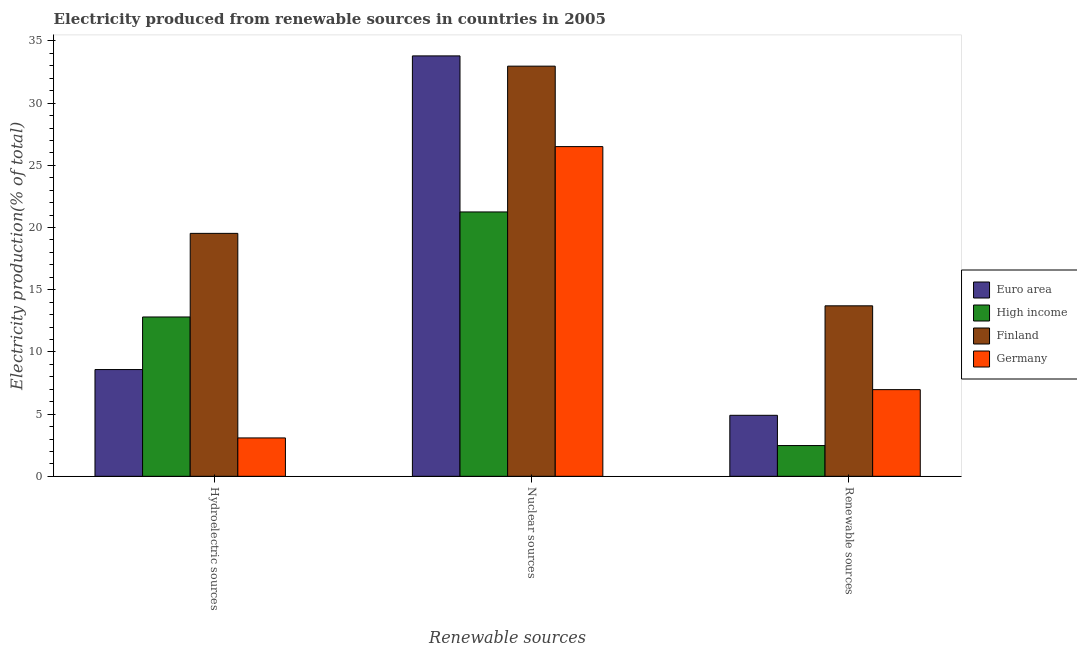How many different coloured bars are there?
Keep it short and to the point. 4. Are the number of bars per tick equal to the number of legend labels?
Offer a very short reply. Yes. Are the number of bars on each tick of the X-axis equal?
Give a very brief answer. Yes. How many bars are there on the 1st tick from the left?
Make the answer very short. 4. What is the label of the 2nd group of bars from the left?
Your response must be concise. Nuclear sources. What is the percentage of electricity produced by nuclear sources in Euro area?
Your response must be concise. 33.8. Across all countries, what is the maximum percentage of electricity produced by hydroelectric sources?
Give a very brief answer. 19.53. Across all countries, what is the minimum percentage of electricity produced by hydroelectric sources?
Offer a terse response. 3.09. In which country was the percentage of electricity produced by renewable sources minimum?
Give a very brief answer. High income. What is the total percentage of electricity produced by nuclear sources in the graph?
Provide a short and direct response. 114.53. What is the difference between the percentage of electricity produced by renewable sources in High income and that in Germany?
Keep it short and to the point. -4.49. What is the difference between the percentage of electricity produced by hydroelectric sources in Euro area and the percentage of electricity produced by nuclear sources in High income?
Your answer should be very brief. -12.67. What is the average percentage of electricity produced by nuclear sources per country?
Your answer should be compact. 28.63. What is the difference between the percentage of electricity produced by nuclear sources and percentage of electricity produced by renewable sources in Germany?
Give a very brief answer. 19.54. What is the ratio of the percentage of electricity produced by renewable sources in Germany to that in High income?
Your answer should be compact. 2.82. Is the percentage of electricity produced by nuclear sources in Euro area less than that in Finland?
Your answer should be compact. No. Is the difference between the percentage of electricity produced by hydroelectric sources in Finland and High income greater than the difference between the percentage of electricity produced by nuclear sources in Finland and High income?
Offer a terse response. No. What is the difference between the highest and the second highest percentage of electricity produced by renewable sources?
Ensure brevity in your answer.  6.74. What is the difference between the highest and the lowest percentage of electricity produced by hydroelectric sources?
Offer a terse response. 16.45. Is the sum of the percentage of electricity produced by hydroelectric sources in Euro area and Germany greater than the maximum percentage of electricity produced by renewable sources across all countries?
Your answer should be very brief. No. What does the 4th bar from the right in Nuclear sources represents?
Give a very brief answer. Euro area. Is it the case that in every country, the sum of the percentage of electricity produced by hydroelectric sources and percentage of electricity produced by nuclear sources is greater than the percentage of electricity produced by renewable sources?
Your answer should be very brief. Yes. What is the difference between two consecutive major ticks on the Y-axis?
Your response must be concise. 5. Does the graph contain any zero values?
Ensure brevity in your answer.  No. Does the graph contain grids?
Offer a terse response. No. Where does the legend appear in the graph?
Offer a terse response. Center right. How are the legend labels stacked?
Offer a very short reply. Vertical. What is the title of the graph?
Provide a short and direct response. Electricity produced from renewable sources in countries in 2005. Does "Gambia, The" appear as one of the legend labels in the graph?
Your answer should be very brief. No. What is the label or title of the X-axis?
Make the answer very short. Renewable sources. What is the Electricity production(% of total) in Euro area in Hydroelectric sources?
Ensure brevity in your answer.  8.58. What is the Electricity production(% of total) in High income in Hydroelectric sources?
Ensure brevity in your answer.  12.81. What is the Electricity production(% of total) of Finland in Hydroelectric sources?
Offer a terse response. 19.53. What is the Electricity production(% of total) in Germany in Hydroelectric sources?
Your answer should be very brief. 3.09. What is the Electricity production(% of total) in Euro area in Nuclear sources?
Your answer should be very brief. 33.8. What is the Electricity production(% of total) in High income in Nuclear sources?
Ensure brevity in your answer.  21.25. What is the Electricity production(% of total) in Finland in Nuclear sources?
Ensure brevity in your answer.  32.97. What is the Electricity production(% of total) of Germany in Nuclear sources?
Give a very brief answer. 26.51. What is the Electricity production(% of total) of Euro area in Renewable sources?
Your response must be concise. 4.91. What is the Electricity production(% of total) in High income in Renewable sources?
Your answer should be compact. 2.47. What is the Electricity production(% of total) of Finland in Renewable sources?
Your answer should be compact. 13.71. What is the Electricity production(% of total) of Germany in Renewable sources?
Provide a succinct answer. 6.97. Across all Renewable sources, what is the maximum Electricity production(% of total) in Euro area?
Ensure brevity in your answer.  33.8. Across all Renewable sources, what is the maximum Electricity production(% of total) in High income?
Your answer should be compact. 21.25. Across all Renewable sources, what is the maximum Electricity production(% of total) in Finland?
Make the answer very short. 32.97. Across all Renewable sources, what is the maximum Electricity production(% of total) in Germany?
Offer a terse response. 26.51. Across all Renewable sources, what is the minimum Electricity production(% of total) in Euro area?
Ensure brevity in your answer.  4.91. Across all Renewable sources, what is the minimum Electricity production(% of total) in High income?
Your response must be concise. 2.47. Across all Renewable sources, what is the minimum Electricity production(% of total) of Finland?
Provide a succinct answer. 13.71. Across all Renewable sources, what is the minimum Electricity production(% of total) of Germany?
Keep it short and to the point. 3.09. What is the total Electricity production(% of total) in Euro area in the graph?
Offer a very short reply. 47.29. What is the total Electricity production(% of total) of High income in the graph?
Provide a succinct answer. 36.54. What is the total Electricity production(% of total) of Finland in the graph?
Give a very brief answer. 66.21. What is the total Electricity production(% of total) of Germany in the graph?
Your answer should be compact. 36.56. What is the difference between the Electricity production(% of total) in Euro area in Hydroelectric sources and that in Nuclear sources?
Provide a succinct answer. -25.22. What is the difference between the Electricity production(% of total) in High income in Hydroelectric sources and that in Nuclear sources?
Provide a succinct answer. -8.44. What is the difference between the Electricity production(% of total) of Finland in Hydroelectric sources and that in Nuclear sources?
Keep it short and to the point. -13.44. What is the difference between the Electricity production(% of total) of Germany in Hydroelectric sources and that in Nuclear sources?
Your answer should be very brief. -23.42. What is the difference between the Electricity production(% of total) in Euro area in Hydroelectric sources and that in Renewable sources?
Make the answer very short. 3.68. What is the difference between the Electricity production(% of total) in High income in Hydroelectric sources and that in Renewable sources?
Offer a very short reply. 10.34. What is the difference between the Electricity production(% of total) in Finland in Hydroelectric sources and that in Renewable sources?
Offer a very short reply. 5.83. What is the difference between the Electricity production(% of total) of Germany in Hydroelectric sources and that in Renewable sources?
Provide a succinct answer. -3.88. What is the difference between the Electricity production(% of total) of Euro area in Nuclear sources and that in Renewable sources?
Keep it short and to the point. 28.89. What is the difference between the Electricity production(% of total) of High income in Nuclear sources and that in Renewable sources?
Offer a very short reply. 18.78. What is the difference between the Electricity production(% of total) of Finland in Nuclear sources and that in Renewable sources?
Offer a very short reply. 19.27. What is the difference between the Electricity production(% of total) of Germany in Nuclear sources and that in Renewable sources?
Give a very brief answer. 19.54. What is the difference between the Electricity production(% of total) of Euro area in Hydroelectric sources and the Electricity production(% of total) of High income in Nuclear sources?
Offer a very short reply. -12.67. What is the difference between the Electricity production(% of total) of Euro area in Hydroelectric sources and the Electricity production(% of total) of Finland in Nuclear sources?
Provide a succinct answer. -24.39. What is the difference between the Electricity production(% of total) of Euro area in Hydroelectric sources and the Electricity production(% of total) of Germany in Nuclear sources?
Offer a very short reply. -17.92. What is the difference between the Electricity production(% of total) in High income in Hydroelectric sources and the Electricity production(% of total) in Finland in Nuclear sources?
Your answer should be compact. -20.17. What is the difference between the Electricity production(% of total) in High income in Hydroelectric sources and the Electricity production(% of total) in Germany in Nuclear sources?
Your answer should be compact. -13.7. What is the difference between the Electricity production(% of total) of Finland in Hydroelectric sources and the Electricity production(% of total) of Germany in Nuclear sources?
Offer a terse response. -6.97. What is the difference between the Electricity production(% of total) of Euro area in Hydroelectric sources and the Electricity production(% of total) of High income in Renewable sources?
Your answer should be very brief. 6.11. What is the difference between the Electricity production(% of total) of Euro area in Hydroelectric sources and the Electricity production(% of total) of Finland in Renewable sources?
Offer a very short reply. -5.12. What is the difference between the Electricity production(% of total) of Euro area in Hydroelectric sources and the Electricity production(% of total) of Germany in Renewable sources?
Your answer should be compact. 1.61. What is the difference between the Electricity production(% of total) of High income in Hydroelectric sources and the Electricity production(% of total) of Finland in Renewable sources?
Your answer should be very brief. -0.9. What is the difference between the Electricity production(% of total) of High income in Hydroelectric sources and the Electricity production(% of total) of Germany in Renewable sources?
Your response must be concise. 5.84. What is the difference between the Electricity production(% of total) in Finland in Hydroelectric sources and the Electricity production(% of total) in Germany in Renewable sources?
Ensure brevity in your answer.  12.56. What is the difference between the Electricity production(% of total) of Euro area in Nuclear sources and the Electricity production(% of total) of High income in Renewable sources?
Provide a succinct answer. 31.32. What is the difference between the Electricity production(% of total) in Euro area in Nuclear sources and the Electricity production(% of total) in Finland in Renewable sources?
Provide a short and direct response. 20.09. What is the difference between the Electricity production(% of total) in Euro area in Nuclear sources and the Electricity production(% of total) in Germany in Renewable sources?
Make the answer very short. 26.83. What is the difference between the Electricity production(% of total) of High income in Nuclear sources and the Electricity production(% of total) of Finland in Renewable sources?
Provide a succinct answer. 7.55. What is the difference between the Electricity production(% of total) in High income in Nuclear sources and the Electricity production(% of total) in Germany in Renewable sources?
Keep it short and to the point. 14.28. What is the difference between the Electricity production(% of total) of Finland in Nuclear sources and the Electricity production(% of total) of Germany in Renewable sources?
Provide a short and direct response. 26.01. What is the average Electricity production(% of total) in Euro area per Renewable sources?
Give a very brief answer. 15.76. What is the average Electricity production(% of total) in High income per Renewable sources?
Make the answer very short. 12.18. What is the average Electricity production(% of total) in Finland per Renewable sources?
Your answer should be compact. 22.07. What is the average Electricity production(% of total) of Germany per Renewable sources?
Offer a very short reply. 12.19. What is the difference between the Electricity production(% of total) of Euro area and Electricity production(% of total) of High income in Hydroelectric sources?
Give a very brief answer. -4.23. What is the difference between the Electricity production(% of total) in Euro area and Electricity production(% of total) in Finland in Hydroelectric sources?
Offer a terse response. -10.95. What is the difference between the Electricity production(% of total) in Euro area and Electricity production(% of total) in Germany in Hydroelectric sources?
Give a very brief answer. 5.5. What is the difference between the Electricity production(% of total) in High income and Electricity production(% of total) in Finland in Hydroelectric sources?
Give a very brief answer. -6.72. What is the difference between the Electricity production(% of total) of High income and Electricity production(% of total) of Germany in Hydroelectric sources?
Ensure brevity in your answer.  9.72. What is the difference between the Electricity production(% of total) in Finland and Electricity production(% of total) in Germany in Hydroelectric sources?
Your answer should be compact. 16.45. What is the difference between the Electricity production(% of total) of Euro area and Electricity production(% of total) of High income in Nuclear sources?
Provide a succinct answer. 12.55. What is the difference between the Electricity production(% of total) of Euro area and Electricity production(% of total) of Finland in Nuclear sources?
Offer a very short reply. 0.82. What is the difference between the Electricity production(% of total) of Euro area and Electricity production(% of total) of Germany in Nuclear sources?
Offer a terse response. 7.29. What is the difference between the Electricity production(% of total) of High income and Electricity production(% of total) of Finland in Nuclear sources?
Offer a very short reply. -11.72. What is the difference between the Electricity production(% of total) of High income and Electricity production(% of total) of Germany in Nuclear sources?
Make the answer very short. -5.25. What is the difference between the Electricity production(% of total) of Finland and Electricity production(% of total) of Germany in Nuclear sources?
Keep it short and to the point. 6.47. What is the difference between the Electricity production(% of total) in Euro area and Electricity production(% of total) in High income in Renewable sources?
Provide a succinct answer. 2.43. What is the difference between the Electricity production(% of total) in Euro area and Electricity production(% of total) in Finland in Renewable sources?
Offer a terse response. -8.8. What is the difference between the Electricity production(% of total) of Euro area and Electricity production(% of total) of Germany in Renewable sources?
Your response must be concise. -2.06. What is the difference between the Electricity production(% of total) of High income and Electricity production(% of total) of Finland in Renewable sources?
Make the answer very short. -11.23. What is the difference between the Electricity production(% of total) in High income and Electricity production(% of total) in Germany in Renewable sources?
Your answer should be compact. -4.49. What is the difference between the Electricity production(% of total) of Finland and Electricity production(% of total) of Germany in Renewable sources?
Provide a short and direct response. 6.74. What is the ratio of the Electricity production(% of total) of Euro area in Hydroelectric sources to that in Nuclear sources?
Provide a short and direct response. 0.25. What is the ratio of the Electricity production(% of total) in High income in Hydroelectric sources to that in Nuclear sources?
Give a very brief answer. 0.6. What is the ratio of the Electricity production(% of total) of Finland in Hydroelectric sources to that in Nuclear sources?
Ensure brevity in your answer.  0.59. What is the ratio of the Electricity production(% of total) of Germany in Hydroelectric sources to that in Nuclear sources?
Give a very brief answer. 0.12. What is the ratio of the Electricity production(% of total) in Euro area in Hydroelectric sources to that in Renewable sources?
Keep it short and to the point. 1.75. What is the ratio of the Electricity production(% of total) in High income in Hydroelectric sources to that in Renewable sources?
Provide a succinct answer. 5.18. What is the ratio of the Electricity production(% of total) of Finland in Hydroelectric sources to that in Renewable sources?
Give a very brief answer. 1.43. What is the ratio of the Electricity production(% of total) of Germany in Hydroelectric sources to that in Renewable sources?
Provide a succinct answer. 0.44. What is the ratio of the Electricity production(% of total) of Euro area in Nuclear sources to that in Renewable sources?
Ensure brevity in your answer.  6.89. What is the ratio of the Electricity production(% of total) of High income in Nuclear sources to that in Renewable sources?
Your answer should be compact. 8.59. What is the ratio of the Electricity production(% of total) in Finland in Nuclear sources to that in Renewable sources?
Provide a short and direct response. 2.41. What is the ratio of the Electricity production(% of total) of Germany in Nuclear sources to that in Renewable sources?
Provide a succinct answer. 3.8. What is the difference between the highest and the second highest Electricity production(% of total) in Euro area?
Make the answer very short. 25.22. What is the difference between the highest and the second highest Electricity production(% of total) in High income?
Offer a very short reply. 8.44. What is the difference between the highest and the second highest Electricity production(% of total) in Finland?
Provide a succinct answer. 13.44. What is the difference between the highest and the second highest Electricity production(% of total) in Germany?
Make the answer very short. 19.54. What is the difference between the highest and the lowest Electricity production(% of total) of Euro area?
Your answer should be very brief. 28.89. What is the difference between the highest and the lowest Electricity production(% of total) of High income?
Give a very brief answer. 18.78. What is the difference between the highest and the lowest Electricity production(% of total) of Finland?
Your answer should be compact. 19.27. What is the difference between the highest and the lowest Electricity production(% of total) of Germany?
Offer a very short reply. 23.42. 